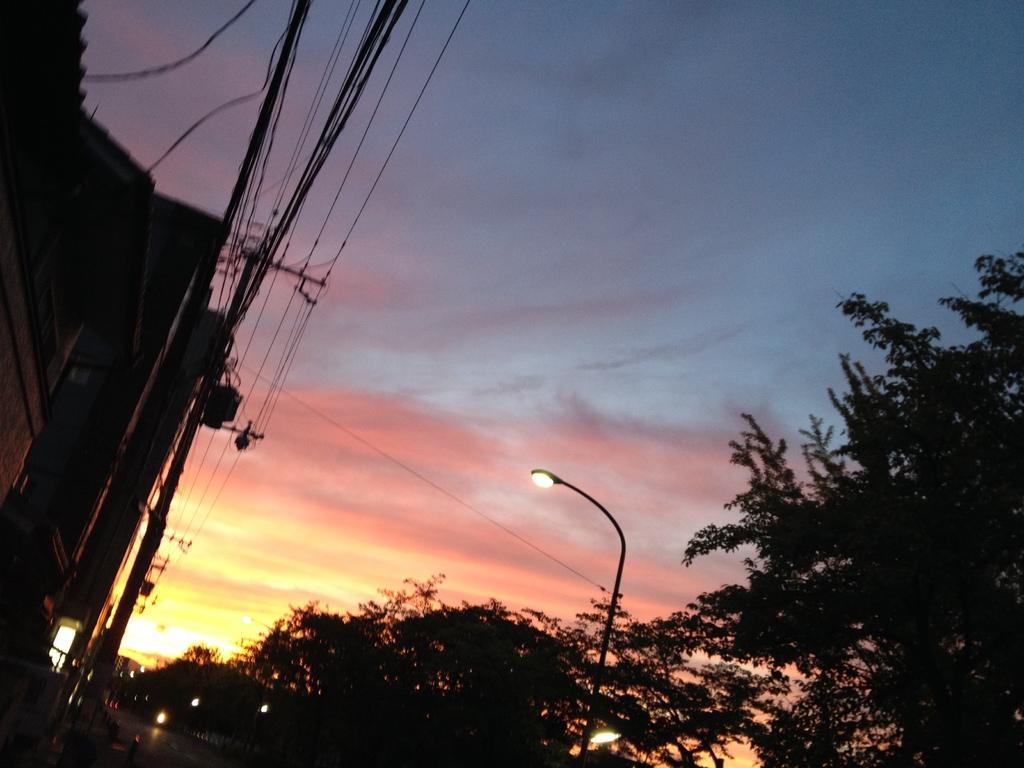How would you summarize this image in a sentence or two? In this image we can see trees, poles, lights, buildings, road, and wires. In the background there is sky. 